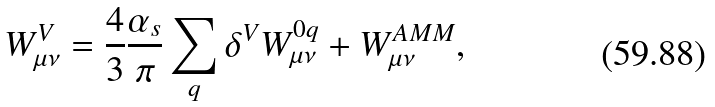Convert formula to latex. <formula><loc_0><loc_0><loc_500><loc_500>W _ { \mu \nu } ^ { V } = \frac { 4 } { 3 } \frac { \alpha _ { s } } { \pi } \sum _ { q } \delta ^ { V } W _ { \mu \nu } ^ { 0 q } + W _ { \mu \nu } ^ { A M M } ,</formula> 